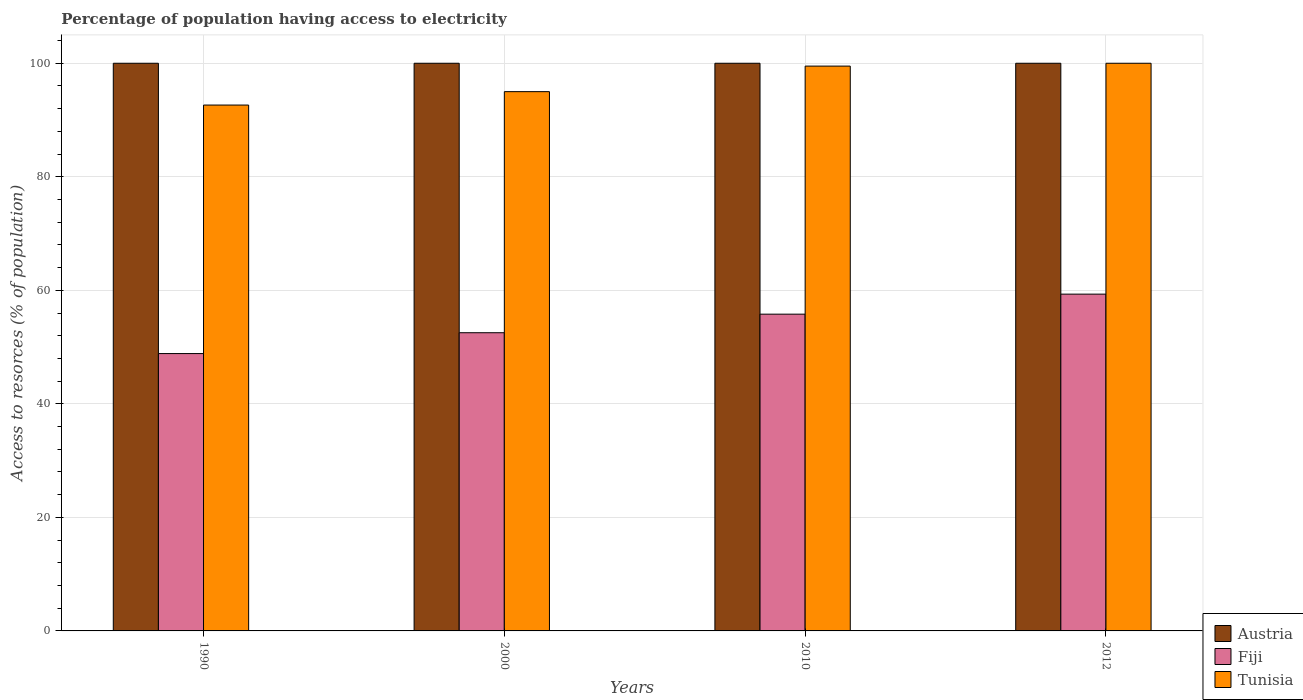How many different coloured bars are there?
Provide a succinct answer. 3. Are the number of bars on each tick of the X-axis equal?
Your response must be concise. Yes. What is the percentage of population having access to electricity in Tunisia in 1990?
Provide a short and direct response. 92.64. Across all years, what is the maximum percentage of population having access to electricity in Austria?
Offer a very short reply. 100. Across all years, what is the minimum percentage of population having access to electricity in Austria?
Offer a very short reply. 100. What is the total percentage of population having access to electricity in Tunisia in the graph?
Keep it short and to the point. 387.14. What is the difference between the percentage of population having access to electricity in Fiji in 2000 and that in 2010?
Provide a short and direct response. -3.27. What is the difference between the percentage of population having access to electricity in Austria in 2000 and the percentage of population having access to electricity in Fiji in 1990?
Provide a short and direct response. 51.14. What is the average percentage of population having access to electricity in Fiji per year?
Give a very brief answer. 54.13. In how many years, is the percentage of population having access to electricity in Tunisia greater than 76 %?
Your answer should be very brief. 4. What is the ratio of the percentage of population having access to electricity in Fiji in 2000 to that in 2012?
Ensure brevity in your answer.  0.89. Is the difference between the percentage of population having access to electricity in Austria in 1990 and 2012 greater than the difference between the percentage of population having access to electricity in Tunisia in 1990 and 2012?
Provide a short and direct response. Yes. What is the difference between the highest and the second highest percentage of population having access to electricity in Fiji?
Your answer should be compact. 3.53. What is the difference between the highest and the lowest percentage of population having access to electricity in Fiji?
Make the answer very short. 10.47. Is the sum of the percentage of population having access to electricity in Tunisia in 1990 and 2010 greater than the maximum percentage of population having access to electricity in Fiji across all years?
Ensure brevity in your answer.  Yes. What does the 2nd bar from the left in 2000 represents?
Give a very brief answer. Fiji. What does the 2nd bar from the right in 2012 represents?
Provide a short and direct response. Fiji. How many years are there in the graph?
Give a very brief answer. 4. What is the difference between two consecutive major ticks on the Y-axis?
Make the answer very short. 20. How many legend labels are there?
Your response must be concise. 3. What is the title of the graph?
Ensure brevity in your answer.  Percentage of population having access to electricity. What is the label or title of the X-axis?
Your answer should be compact. Years. What is the label or title of the Y-axis?
Offer a very short reply. Access to resorces (% of population). What is the Access to resorces (% of population) in Fiji in 1990?
Your answer should be very brief. 48.86. What is the Access to resorces (% of population) of Tunisia in 1990?
Ensure brevity in your answer.  92.64. What is the Access to resorces (% of population) of Austria in 2000?
Your response must be concise. 100. What is the Access to resorces (% of population) in Fiji in 2000?
Your answer should be very brief. 52.53. What is the Access to resorces (% of population) in Tunisia in 2000?
Your response must be concise. 95. What is the Access to resorces (% of population) of Fiji in 2010?
Your answer should be compact. 55.8. What is the Access to resorces (% of population) of Tunisia in 2010?
Your answer should be compact. 99.5. What is the Access to resorces (% of population) of Austria in 2012?
Ensure brevity in your answer.  100. What is the Access to resorces (% of population) of Fiji in 2012?
Provide a succinct answer. 59.33. Across all years, what is the maximum Access to resorces (% of population) of Austria?
Make the answer very short. 100. Across all years, what is the maximum Access to resorces (% of population) of Fiji?
Offer a terse response. 59.33. Across all years, what is the maximum Access to resorces (% of population) of Tunisia?
Offer a very short reply. 100. Across all years, what is the minimum Access to resorces (% of population) in Austria?
Your answer should be compact. 100. Across all years, what is the minimum Access to resorces (% of population) of Fiji?
Give a very brief answer. 48.86. Across all years, what is the minimum Access to resorces (% of population) of Tunisia?
Keep it short and to the point. 92.64. What is the total Access to resorces (% of population) in Fiji in the graph?
Ensure brevity in your answer.  216.52. What is the total Access to resorces (% of population) in Tunisia in the graph?
Give a very brief answer. 387.14. What is the difference between the Access to resorces (% of population) in Austria in 1990 and that in 2000?
Your answer should be very brief. 0. What is the difference between the Access to resorces (% of population) in Fiji in 1990 and that in 2000?
Offer a terse response. -3.67. What is the difference between the Access to resorces (% of population) in Tunisia in 1990 and that in 2000?
Offer a very short reply. -2.36. What is the difference between the Access to resorces (% of population) in Fiji in 1990 and that in 2010?
Provide a short and direct response. -6.94. What is the difference between the Access to resorces (% of population) of Tunisia in 1990 and that in 2010?
Give a very brief answer. -6.86. What is the difference between the Access to resorces (% of population) in Austria in 1990 and that in 2012?
Your answer should be compact. 0. What is the difference between the Access to resorces (% of population) of Fiji in 1990 and that in 2012?
Keep it short and to the point. -10.47. What is the difference between the Access to resorces (% of population) in Tunisia in 1990 and that in 2012?
Offer a very short reply. -7.36. What is the difference between the Access to resorces (% of population) of Austria in 2000 and that in 2010?
Your answer should be compact. 0. What is the difference between the Access to resorces (% of population) in Fiji in 2000 and that in 2010?
Your answer should be compact. -3.27. What is the difference between the Access to resorces (% of population) in Fiji in 2000 and that in 2012?
Keep it short and to the point. -6.8. What is the difference between the Access to resorces (% of population) of Fiji in 2010 and that in 2012?
Your answer should be very brief. -3.53. What is the difference between the Access to resorces (% of population) of Austria in 1990 and the Access to resorces (% of population) of Fiji in 2000?
Give a very brief answer. 47.47. What is the difference between the Access to resorces (% of population) of Fiji in 1990 and the Access to resorces (% of population) of Tunisia in 2000?
Make the answer very short. -46.14. What is the difference between the Access to resorces (% of population) of Austria in 1990 and the Access to resorces (% of population) of Fiji in 2010?
Your answer should be compact. 44.2. What is the difference between the Access to resorces (% of population) in Fiji in 1990 and the Access to resorces (% of population) in Tunisia in 2010?
Make the answer very short. -50.64. What is the difference between the Access to resorces (% of population) of Austria in 1990 and the Access to resorces (% of population) of Fiji in 2012?
Make the answer very short. 40.67. What is the difference between the Access to resorces (% of population) in Fiji in 1990 and the Access to resorces (% of population) in Tunisia in 2012?
Provide a short and direct response. -51.14. What is the difference between the Access to resorces (% of population) in Austria in 2000 and the Access to resorces (% of population) in Fiji in 2010?
Your response must be concise. 44.2. What is the difference between the Access to resorces (% of population) in Austria in 2000 and the Access to resorces (% of population) in Tunisia in 2010?
Your answer should be compact. 0.5. What is the difference between the Access to resorces (% of population) of Fiji in 2000 and the Access to resorces (% of population) of Tunisia in 2010?
Give a very brief answer. -46.97. What is the difference between the Access to resorces (% of population) of Austria in 2000 and the Access to resorces (% of population) of Fiji in 2012?
Provide a short and direct response. 40.67. What is the difference between the Access to resorces (% of population) of Fiji in 2000 and the Access to resorces (% of population) of Tunisia in 2012?
Your answer should be very brief. -47.47. What is the difference between the Access to resorces (% of population) in Austria in 2010 and the Access to resorces (% of population) in Fiji in 2012?
Provide a succinct answer. 40.67. What is the difference between the Access to resorces (% of population) in Fiji in 2010 and the Access to resorces (% of population) in Tunisia in 2012?
Give a very brief answer. -44.2. What is the average Access to resorces (% of population) of Austria per year?
Ensure brevity in your answer.  100. What is the average Access to resorces (% of population) in Fiji per year?
Your answer should be compact. 54.13. What is the average Access to resorces (% of population) in Tunisia per year?
Your response must be concise. 96.78. In the year 1990, what is the difference between the Access to resorces (% of population) of Austria and Access to resorces (% of population) of Fiji?
Give a very brief answer. 51.14. In the year 1990, what is the difference between the Access to resorces (% of population) in Austria and Access to resorces (% of population) in Tunisia?
Offer a very short reply. 7.36. In the year 1990, what is the difference between the Access to resorces (% of population) in Fiji and Access to resorces (% of population) in Tunisia?
Provide a short and direct response. -43.78. In the year 2000, what is the difference between the Access to resorces (% of population) in Austria and Access to resorces (% of population) in Fiji?
Provide a succinct answer. 47.47. In the year 2000, what is the difference between the Access to resorces (% of population) of Austria and Access to resorces (% of population) of Tunisia?
Your answer should be very brief. 5. In the year 2000, what is the difference between the Access to resorces (% of population) in Fiji and Access to resorces (% of population) in Tunisia?
Offer a terse response. -42.47. In the year 2010, what is the difference between the Access to resorces (% of population) in Austria and Access to resorces (% of population) in Fiji?
Your answer should be very brief. 44.2. In the year 2010, what is the difference between the Access to resorces (% of population) of Fiji and Access to resorces (% of population) of Tunisia?
Your answer should be very brief. -43.7. In the year 2012, what is the difference between the Access to resorces (% of population) in Austria and Access to resorces (% of population) in Fiji?
Offer a very short reply. 40.67. In the year 2012, what is the difference between the Access to resorces (% of population) of Fiji and Access to resorces (% of population) of Tunisia?
Give a very brief answer. -40.67. What is the ratio of the Access to resorces (% of population) of Fiji in 1990 to that in 2000?
Your response must be concise. 0.93. What is the ratio of the Access to resorces (% of population) in Tunisia in 1990 to that in 2000?
Offer a terse response. 0.98. What is the ratio of the Access to resorces (% of population) of Austria in 1990 to that in 2010?
Keep it short and to the point. 1. What is the ratio of the Access to resorces (% of population) of Fiji in 1990 to that in 2010?
Your response must be concise. 0.88. What is the ratio of the Access to resorces (% of population) of Austria in 1990 to that in 2012?
Offer a very short reply. 1. What is the ratio of the Access to resorces (% of population) of Fiji in 1990 to that in 2012?
Your answer should be compact. 0.82. What is the ratio of the Access to resorces (% of population) of Tunisia in 1990 to that in 2012?
Keep it short and to the point. 0.93. What is the ratio of the Access to resorces (% of population) of Austria in 2000 to that in 2010?
Keep it short and to the point. 1. What is the ratio of the Access to resorces (% of population) in Fiji in 2000 to that in 2010?
Offer a terse response. 0.94. What is the ratio of the Access to resorces (% of population) of Tunisia in 2000 to that in 2010?
Offer a terse response. 0.95. What is the ratio of the Access to resorces (% of population) of Austria in 2000 to that in 2012?
Ensure brevity in your answer.  1. What is the ratio of the Access to resorces (% of population) in Fiji in 2000 to that in 2012?
Your answer should be compact. 0.89. What is the ratio of the Access to resorces (% of population) of Austria in 2010 to that in 2012?
Give a very brief answer. 1. What is the ratio of the Access to resorces (% of population) of Fiji in 2010 to that in 2012?
Offer a terse response. 0.94. What is the ratio of the Access to resorces (% of population) of Tunisia in 2010 to that in 2012?
Give a very brief answer. 0.99. What is the difference between the highest and the second highest Access to resorces (% of population) in Austria?
Offer a terse response. 0. What is the difference between the highest and the second highest Access to resorces (% of population) of Fiji?
Offer a terse response. 3.53. What is the difference between the highest and the second highest Access to resorces (% of population) of Tunisia?
Make the answer very short. 0.5. What is the difference between the highest and the lowest Access to resorces (% of population) of Austria?
Provide a short and direct response. 0. What is the difference between the highest and the lowest Access to resorces (% of population) of Fiji?
Ensure brevity in your answer.  10.47. What is the difference between the highest and the lowest Access to resorces (% of population) in Tunisia?
Your answer should be very brief. 7.36. 